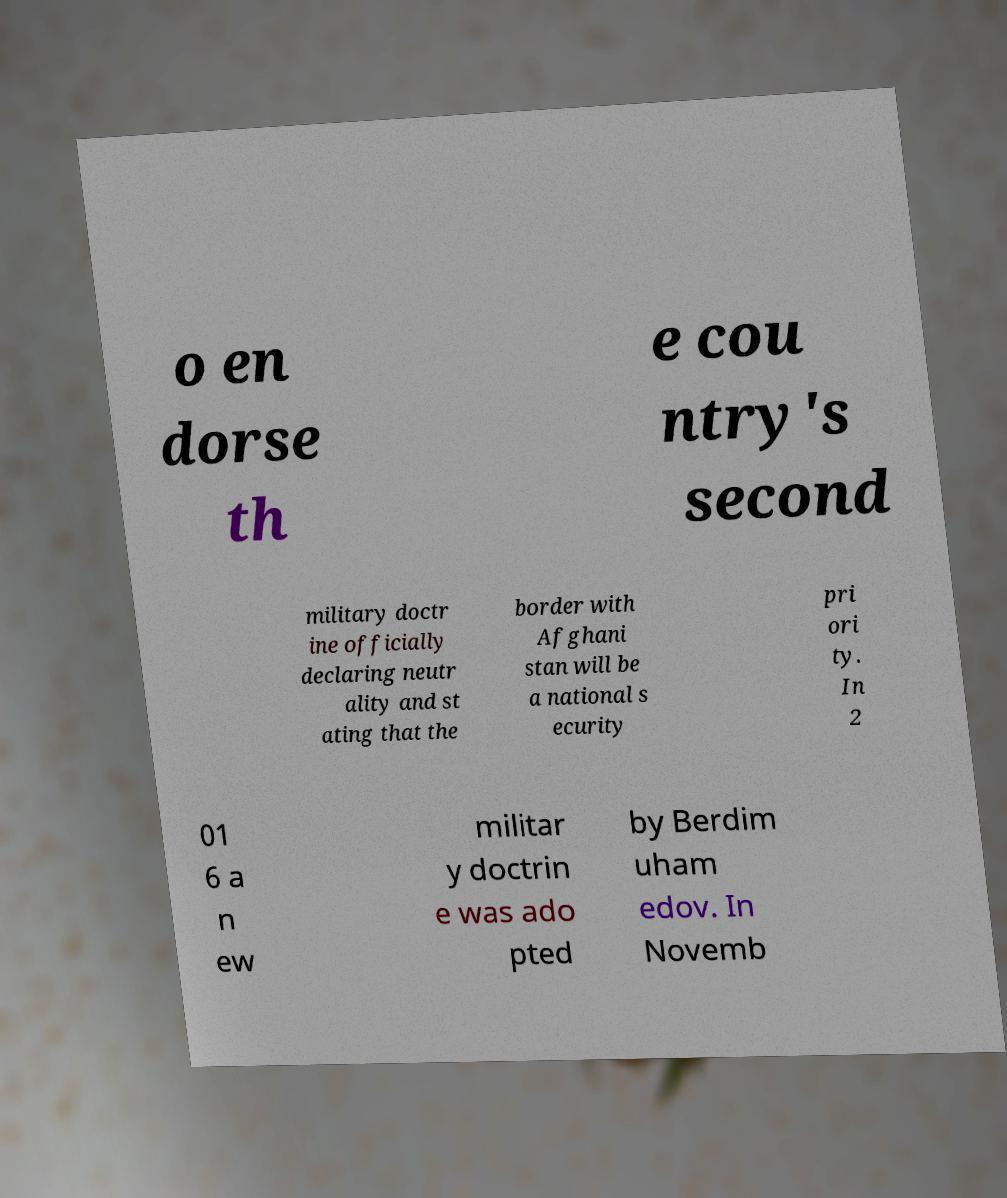Can you accurately transcribe the text from the provided image for me? o en dorse th e cou ntry's second military doctr ine officially declaring neutr ality and st ating that the border with Afghani stan will be a national s ecurity pri ori ty. In 2 01 6 a n ew militar y doctrin e was ado pted by Berdim uham edov. In Novemb 